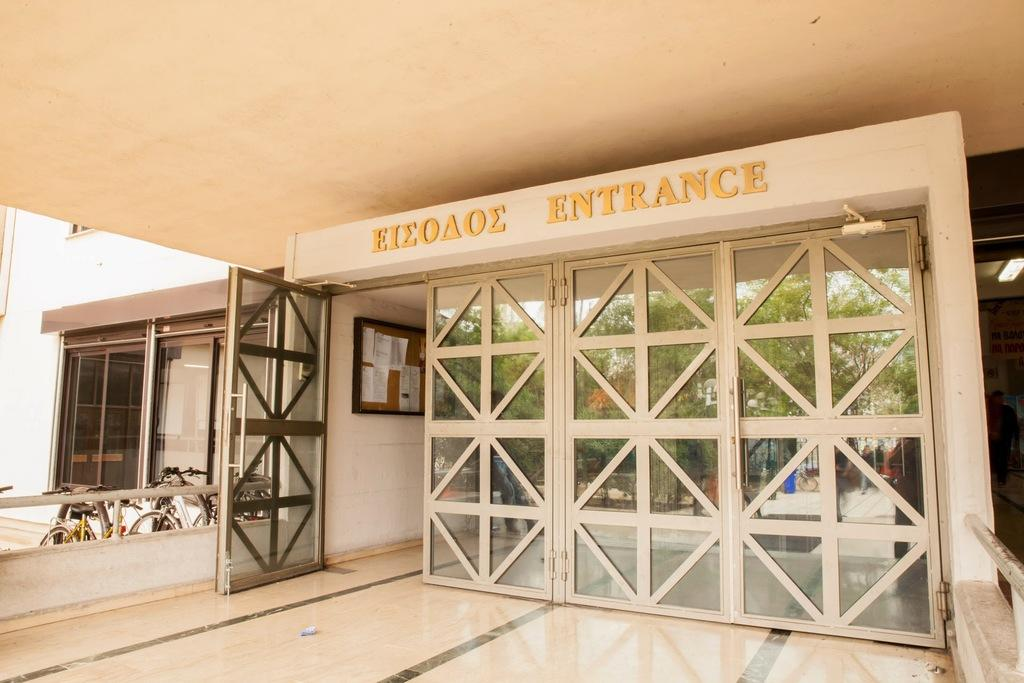What type of structure is visible in the image? There is a building in the image. What can be used to enter or exit the building? There are doors in the image. What mode of transportation can be seen in the image? There are bicycles in the image. What are the long, thin objects in the image? There are rods in the image. What type of paper items are present in the image? There are papers in the image. What is attached to the wall in the image? There is a board on the wall in the image. What provides illumination in the image? There is a light in the image. What is at the bottom of the image? There is a floor at the bottom of the image. What type of scarf is draped over the bicycle in the image? There is no scarf present in the image; it only features a building, doors, bicycles, rods, papers, a board, a light, and a floor. 